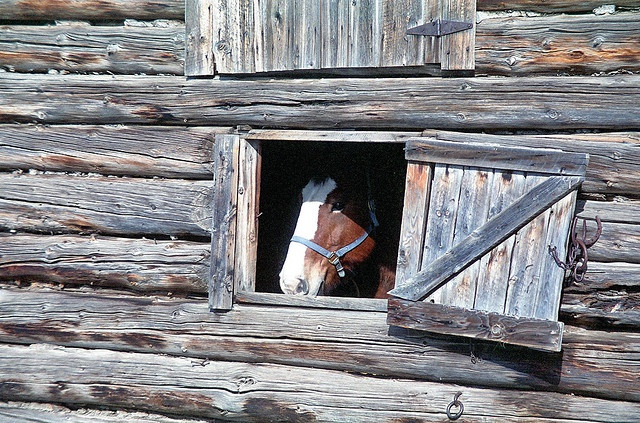Describe the objects in this image and their specific colors. I can see a horse in darkgray, black, white, brown, and maroon tones in this image. 